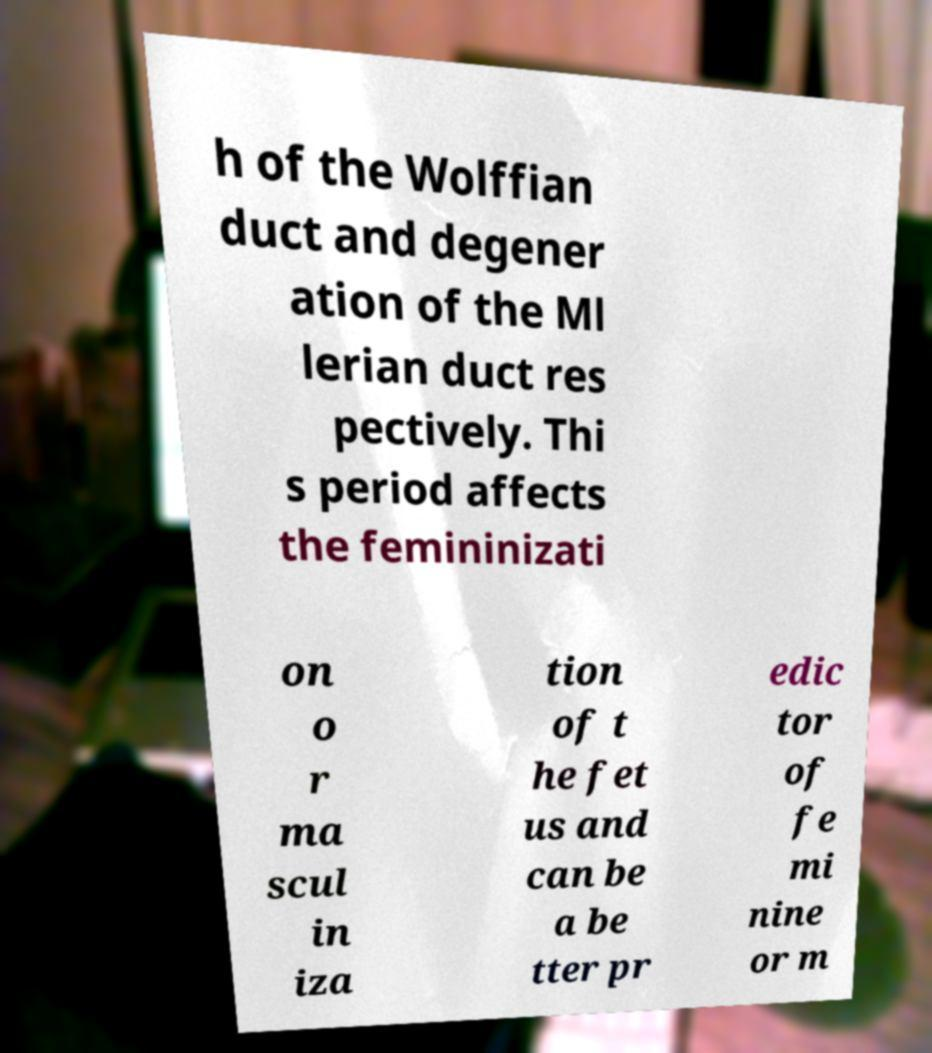Could you assist in decoding the text presented in this image and type it out clearly? h of the Wolffian duct and degener ation of the Ml lerian duct res pectively. Thi s period affects the femininizati on o r ma scul in iza tion of t he fet us and can be a be tter pr edic tor of fe mi nine or m 